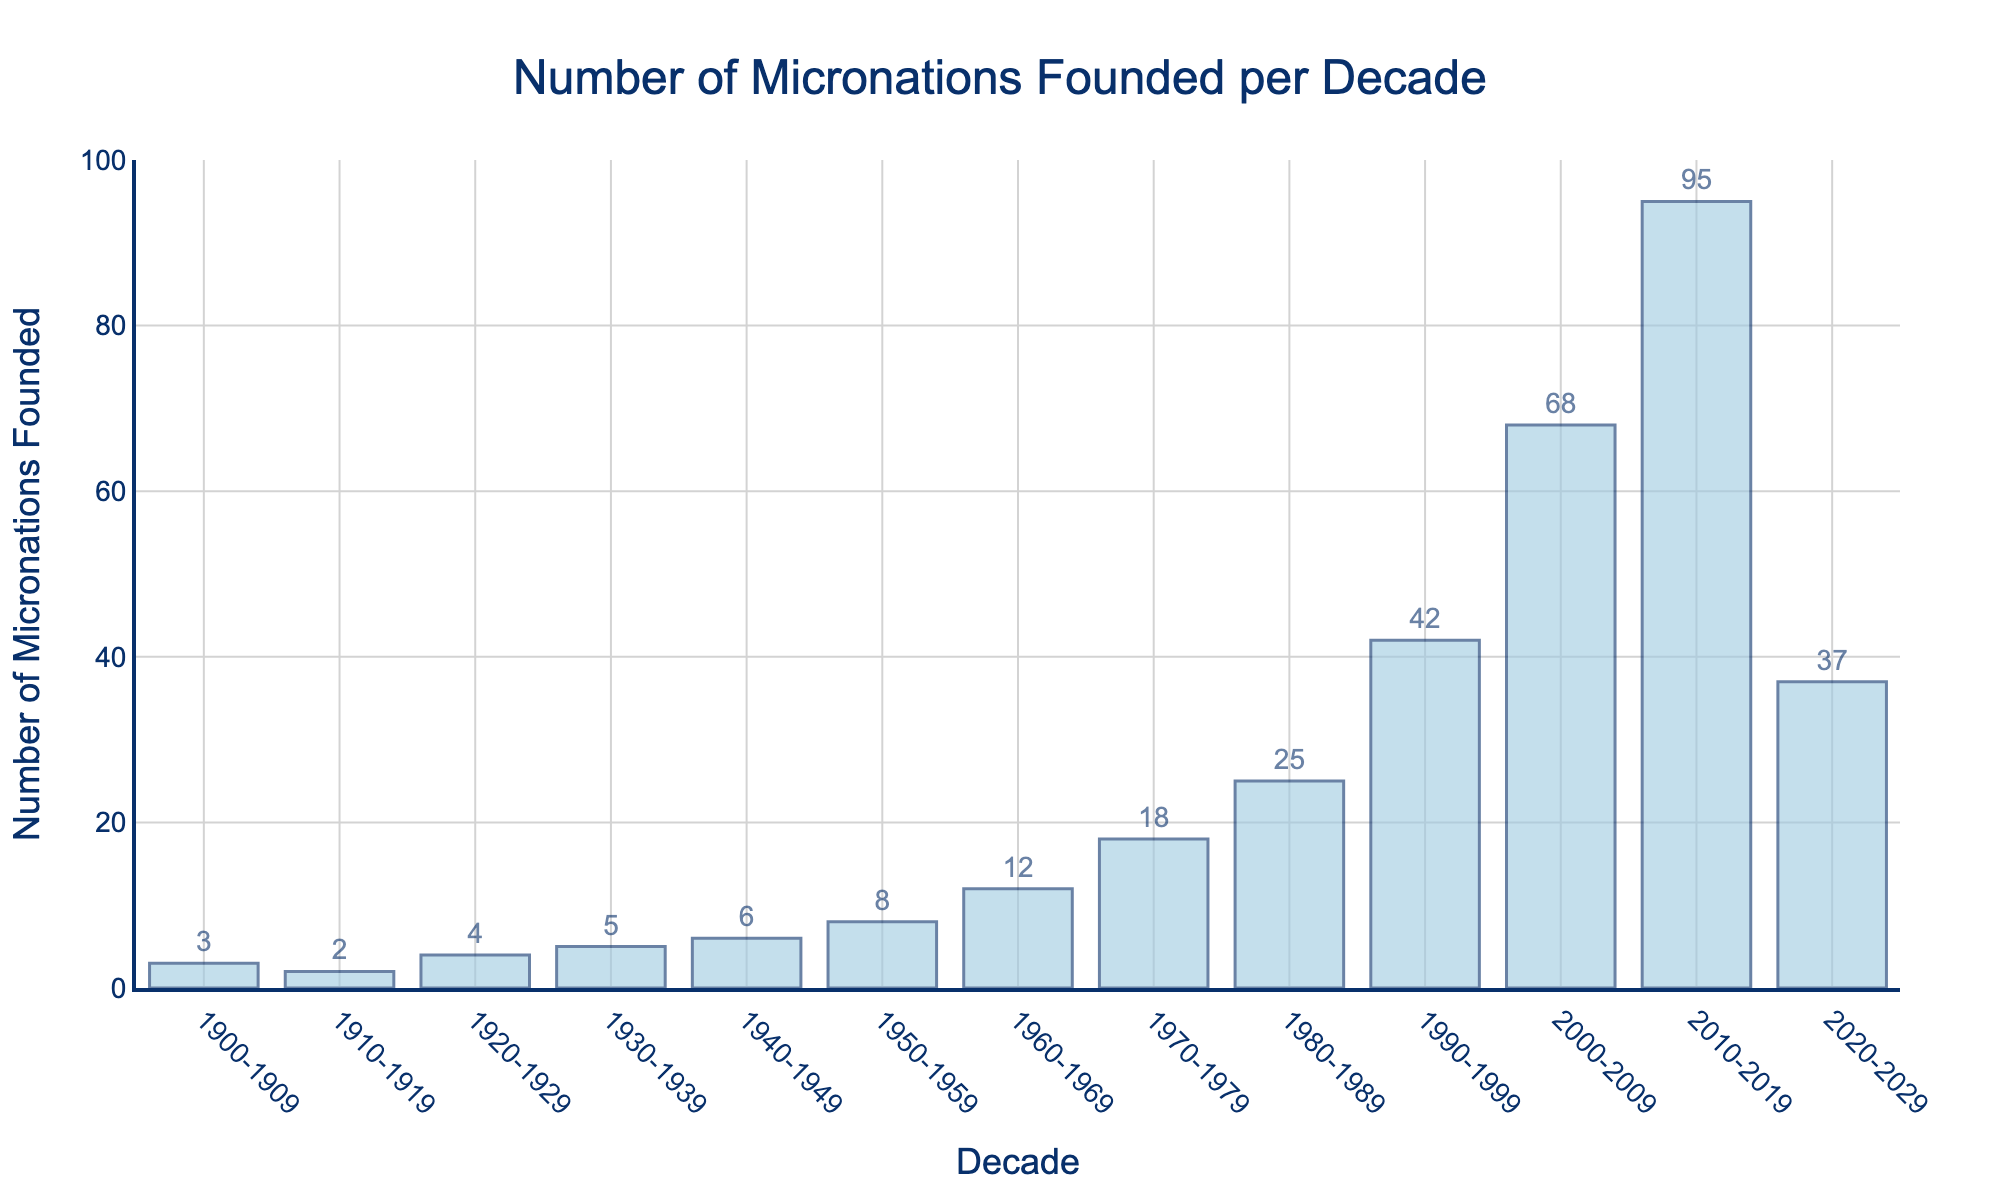Which decade saw the highest number of micronations founded? The decade 2010-2019 has the highest bar on the chart. Count the value displayed on top of that bar, which is 95.
Answer: 2010-2019 How many total micronations were founded from 1900 to 1939? Add the number of micronations founded in each decade from 1900-1909 to 1930-1939: 3 + 2 + 4 + 5 = 14.
Answer: 14 What is the difference in the number of micronations founded between the decades 2000-2009 and 2020-2029? Subtract the number of micronations for the decade 2020-2029 from the number for the decade 2000-2009: 68 - 37 = 31.
Answer: 31 Which decade experienced a greater increase in the number of micronations founded: 1990-1999 to 2000-2009 or 2000-2009 to 2010-2019? Calculate the increase for each period: 
Between 1990-1999 and 2000-2009: 68 - 42 = 26. 
Between 2000-2009 and 2010-2019: 95 - 68 = 27. 
Compare the values: 27 is greater than 26.
Answer: 2000-2009 to 2010-2019 How many more micronations were created in the 2010s compared to the 1950s? Subtract the number of micronations in the 1950s from the number in the 2010s: 95 - 8 = 87.
Answer: 87 What's the average number of micronations founded per decade from 1900 to 2019? Sum the number of micronations founded each decade from 1900-2019 and then divide by the number of decades (12): (3 + 2 + 4 + 5 + 6 + 8 + 12 + 18 + 25 + 42 + 68 + 95) / 12 ≈ 24.25.
Answer: 24.25 In which decade did the number of micronations founded double compared to the previous decade for the first time? Compare each decade's micronations with the previous one: 
1910-1919 vs. 1900-1909: 2 ≠ 2*3, 
1920-1929 vs. 1910-1919: 4 ≠ 2*2, 
1930-1939 vs. 1920-1929: 5 ≠ 2*4, 
1940-1949 vs. 1930-1939: 6 ≠ 2*5, 
1950-1959 vs. 1940-1949: 8 ≠ 2*6, 
1960-1969 vs. 1950-1959: 12 ≠ 2*8, 
1970-1979 vs. 1960-1969: 18 ≠ 2*12, 
1980-1989 vs. 1970-1979: 25 ≠ 2*18, 
1990-1999 vs. 1980-1989: 42 ≈ 2*25. The significant doubling first happens between 1980-1989 and 1990-1999.
Answer: 1990-1999 